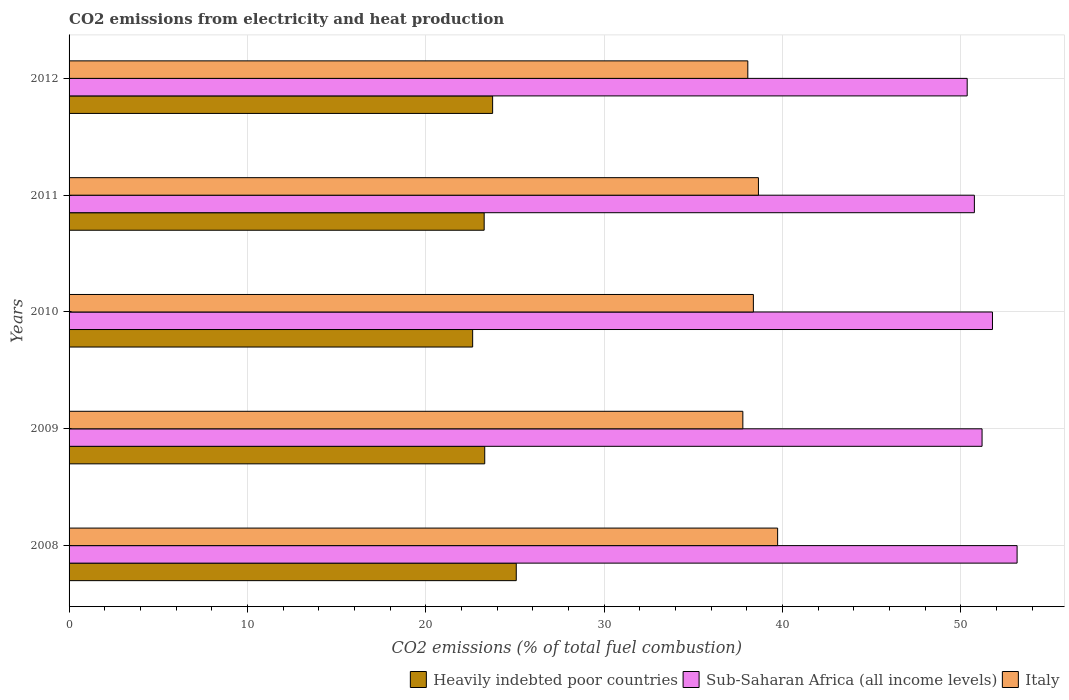How many different coloured bars are there?
Give a very brief answer. 3. How many groups of bars are there?
Offer a very short reply. 5. How many bars are there on the 2nd tick from the bottom?
Offer a terse response. 3. What is the label of the 4th group of bars from the top?
Your answer should be very brief. 2009. In how many cases, is the number of bars for a given year not equal to the number of legend labels?
Provide a succinct answer. 0. What is the amount of CO2 emitted in Sub-Saharan Africa (all income levels) in 2009?
Your response must be concise. 51.2. Across all years, what is the maximum amount of CO2 emitted in Sub-Saharan Africa (all income levels)?
Make the answer very short. 53.16. Across all years, what is the minimum amount of CO2 emitted in Heavily indebted poor countries?
Offer a terse response. 22.63. In which year was the amount of CO2 emitted in Heavily indebted poor countries minimum?
Offer a terse response. 2010. What is the total amount of CO2 emitted in Sub-Saharan Africa (all income levels) in the graph?
Offer a terse response. 257.26. What is the difference between the amount of CO2 emitted in Sub-Saharan Africa (all income levels) in 2008 and that in 2010?
Your answer should be very brief. 1.38. What is the difference between the amount of CO2 emitted in Italy in 2010 and the amount of CO2 emitted in Heavily indebted poor countries in 2009?
Offer a very short reply. 15.06. What is the average amount of CO2 emitted in Italy per year?
Offer a very short reply. 38.52. In the year 2009, what is the difference between the amount of CO2 emitted in Heavily indebted poor countries and amount of CO2 emitted in Sub-Saharan Africa (all income levels)?
Provide a short and direct response. -27.89. In how many years, is the amount of CO2 emitted in Heavily indebted poor countries greater than 42 %?
Ensure brevity in your answer.  0. What is the ratio of the amount of CO2 emitted in Italy in 2008 to that in 2012?
Give a very brief answer. 1.04. Is the amount of CO2 emitted in Sub-Saharan Africa (all income levels) in 2008 less than that in 2011?
Your answer should be compact. No. Is the difference between the amount of CO2 emitted in Heavily indebted poor countries in 2011 and 2012 greater than the difference between the amount of CO2 emitted in Sub-Saharan Africa (all income levels) in 2011 and 2012?
Ensure brevity in your answer.  No. What is the difference between the highest and the second highest amount of CO2 emitted in Italy?
Offer a very short reply. 1.08. What is the difference between the highest and the lowest amount of CO2 emitted in Heavily indebted poor countries?
Give a very brief answer. 2.45. Is the sum of the amount of CO2 emitted in Sub-Saharan Africa (all income levels) in 2011 and 2012 greater than the maximum amount of CO2 emitted in Heavily indebted poor countries across all years?
Offer a very short reply. Yes. What does the 2nd bar from the top in 2009 represents?
Your answer should be very brief. Sub-Saharan Africa (all income levels). What does the 2nd bar from the bottom in 2010 represents?
Ensure brevity in your answer.  Sub-Saharan Africa (all income levels). Is it the case that in every year, the sum of the amount of CO2 emitted in Sub-Saharan Africa (all income levels) and amount of CO2 emitted in Heavily indebted poor countries is greater than the amount of CO2 emitted in Italy?
Make the answer very short. Yes. Are all the bars in the graph horizontal?
Keep it short and to the point. Yes. How many years are there in the graph?
Your answer should be very brief. 5. Does the graph contain any zero values?
Keep it short and to the point. No. Does the graph contain grids?
Ensure brevity in your answer.  Yes. How many legend labels are there?
Give a very brief answer. 3. How are the legend labels stacked?
Provide a succinct answer. Horizontal. What is the title of the graph?
Your answer should be very brief. CO2 emissions from electricity and heat production. What is the label or title of the X-axis?
Offer a terse response. CO2 emissions (% of total fuel combustion). What is the CO2 emissions (% of total fuel combustion) in Heavily indebted poor countries in 2008?
Give a very brief answer. 25.08. What is the CO2 emissions (% of total fuel combustion) in Sub-Saharan Africa (all income levels) in 2008?
Your answer should be compact. 53.16. What is the CO2 emissions (% of total fuel combustion) of Italy in 2008?
Make the answer very short. 39.73. What is the CO2 emissions (% of total fuel combustion) of Heavily indebted poor countries in 2009?
Your answer should be very brief. 23.31. What is the CO2 emissions (% of total fuel combustion) in Sub-Saharan Africa (all income levels) in 2009?
Give a very brief answer. 51.2. What is the CO2 emissions (% of total fuel combustion) in Italy in 2009?
Your response must be concise. 37.78. What is the CO2 emissions (% of total fuel combustion) in Heavily indebted poor countries in 2010?
Your answer should be compact. 22.63. What is the CO2 emissions (% of total fuel combustion) of Sub-Saharan Africa (all income levels) in 2010?
Provide a succinct answer. 51.78. What is the CO2 emissions (% of total fuel combustion) of Italy in 2010?
Make the answer very short. 38.37. What is the CO2 emissions (% of total fuel combustion) of Heavily indebted poor countries in 2011?
Your answer should be compact. 23.28. What is the CO2 emissions (% of total fuel combustion) of Sub-Saharan Africa (all income levels) in 2011?
Your response must be concise. 50.77. What is the CO2 emissions (% of total fuel combustion) in Italy in 2011?
Offer a terse response. 38.66. What is the CO2 emissions (% of total fuel combustion) of Heavily indebted poor countries in 2012?
Your response must be concise. 23.75. What is the CO2 emissions (% of total fuel combustion) of Sub-Saharan Africa (all income levels) in 2012?
Offer a terse response. 50.36. What is the CO2 emissions (% of total fuel combustion) of Italy in 2012?
Your answer should be compact. 38.06. Across all years, what is the maximum CO2 emissions (% of total fuel combustion) in Heavily indebted poor countries?
Your answer should be compact. 25.08. Across all years, what is the maximum CO2 emissions (% of total fuel combustion) of Sub-Saharan Africa (all income levels)?
Make the answer very short. 53.16. Across all years, what is the maximum CO2 emissions (% of total fuel combustion) of Italy?
Your answer should be compact. 39.73. Across all years, what is the minimum CO2 emissions (% of total fuel combustion) of Heavily indebted poor countries?
Offer a terse response. 22.63. Across all years, what is the minimum CO2 emissions (% of total fuel combustion) of Sub-Saharan Africa (all income levels)?
Your answer should be compact. 50.36. Across all years, what is the minimum CO2 emissions (% of total fuel combustion) of Italy?
Offer a terse response. 37.78. What is the total CO2 emissions (% of total fuel combustion) in Heavily indebted poor countries in the graph?
Offer a very short reply. 118.04. What is the total CO2 emissions (% of total fuel combustion) of Sub-Saharan Africa (all income levels) in the graph?
Provide a short and direct response. 257.26. What is the total CO2 emissions (% of total fuel combustion) of Italy in the graph?
Keep it short and to the point. 192.6. What is the difference between the CO2 emissions (% of total fuel combustion) of Heavily indebted poor countries in 2008 and that in 2009?
Offer a very short reply. 1.77. What is the difference between the CO2 emissions (% of total fuel combustion) in Sub-Saharan Africa (all income levels) in 2008 and that in 2009?
Your answer should be compact. 1.96. What is the difference between the CO2 emissions (% of total fuel combustion) of Italy in 2008 and that in 2009?
Your answer should be compact. 1.95. What is the difference between the CO2 emissions (% of total fuel combustion) in Heavily indebted poor countries in 2008 and that in 2010?
Your answer should be very brief. 2.45. What is the difference between the CO2 emissions (% of total fuel combustion) in Sub-Saharan Africa (all income levels) in 2008 and that in 2010?
Your response must be concise. 1.38. What is the difference between the CO2 emissions (% of total fuel combustion) of Italy in 2008 and that in 2010?
Your answer should be very brief. 1.36. What is the difference between the CO2 emissions (% of total fuel combustion) in Heavily indebted poor countries in 2008 and that in 2011?
Your answer should be compact. 1.8. What is the difference between the CO2 emissions (% of total fuel combustion) in Sub-Saharan Africa (all income levels) in 2008 and that in 2011?
Provide a succinct answer. 2.4. What is the difference between the CO2 emissions (% of total fuel combustion) of Italy in 2008 and that in 2011?
Ensure brevity in your answer.  1.08. What is the difference between the CO2 emissions (% of total fuel combustion) of Heavily indebted poor countries in 2008 and that in 2012?
Offer a terse response. 1.33. What is the difference between the CO2 emissions (% of total fuel combustion) of Sub-Saharan Africa (all income levels) in 2008 and that in 2012?
Give a very brief answer. 2.8. What is the difference between the CO2 emissions (% of total fuel combustion) of Italy in 2008 and that in 2012?
Ensure brevity in your answer.  1.67. What is the difference between the CO2 emissions (% of total fuel combustion) in Heavily indebted poor countries in 2009 and that in 2010?
Your response must be concise. 0.68. What is the difference between the CO2 emissions (% of total fuel combustion) of Sub-Saharan Africa (all income levels) in 2009 and that in 2010?
Your answer should be very brief. -0.58. What is the difference between the CO2 emissions (% of total fuel combustion) in Italy in 2009 and that in 2010?
Provide a short and direct response. -0.59. What is the difference between the CO2 emissions (% of total fuel combustion) in Heavily indebted poor countries in 2009 and that in 2011?
Provide a short and direct response. 0.03. What is the difference between the CO2 emissions (% of total fuel combustion) of Sub-Saharan Africa (all income levels) in 2009 and that in 2011?
Make the answer very short. 0.43. What is the difference between the CO2 emissions (% of total fuel combustion) of Italy in 2009 and that in 2011?
Keep it short and to the point. -0.87. What is the difference between the CO2 emissions (% of total fuel combustion) of Heavily indebted poor countries in 2009 and that in 2012?
Offer a terse response. -0.44. What is the difference between the CO2 emissions (% of total fuel combustion) of Sub-Saharan Africa (all income levels) in 2009 and that in 2012?
Provide a succinct answer. 0.83. What is the difference between the CO2 emissions (% of total fuel combustion) of Italy in 2009 and that in 2012?
Your answer should be compact. -0.28. What is the difference between the CO2 emissions (% of total fuel combustion) in Heavily indebted poor countries in 2010 and that in 2011?
Provide a short and direct response. -0.65. What is the difference between the CO2 emissions (% of total fuel combustion) of Sub-Saharan Africa (all income levels) in 2010 and that in 2011?
Your answer should be very brief. 1.01. What is the difference between the CO2 emissions (% of total fuel combustion) of Italy in 2010 and that in 2011?
Keep it short and to the point. -0.28. What is the difference between the CO2 emissions (% of total fuel combustion) in Heavily indebted poor countries in 2010 and that in 2012?
Provide a short and direct response. -1.12. What is the difference between the CO2 emissions (% of total fuel combustion) in Sub-Saharan Africa (all income levels) in 2010 and that in 2012?
Give a very brief answer. 1.42. What is the difference between the CO2 emissions (% of total fuel combustion) in Italy in 2010 and that in 2012?
Your response must be concise. 0.31. What is the difference between the CO2 emissions (% of total fuel combustion) in Heavily indebted poor countries in 2011 and that in 2012?
Give a very brief answer. -0.47. What is the difference between the CO2 emissions (% of total fuel combustion) of Sub-Saharan Africa (all income levels) in 2011 and that in 2012?
Make the answer very short. 0.4. What is the difference between the CO2 emissions (% of total fuel combustion) in Italy in 2011 and that in 2012?
Make the answer very short. 0.6. What is the difference between the CO2 emissions (% of total fuel combustion) of Heavily indebted poor countries in 2008 and the CO2 emissions (% of total fuel combustion) of Sub-Saharan Africa (all income levels) in 2009?
Provide a short and direct response. -26.12. What is the difference between the CO2 emissions (% of total fuel combustion) of Heavily indebted poor countries in 2008 and the CO2 emissions (% of total fuel combustion) of Italy in 2009?
Give a very brief answer. -12.71. What is the difference between the CO2 emissions (% of total fuel combustion) in Sub-Saharan Africa (all income levels) in 2008 and the CO2 emissions (% of total fuel combustion) in Italy in 2009?
Your response must be concise. 15.38. What is the difference between the CO2 emissions (% of total fuel combustion) in Heavily indebted poor countries in 2008 and the CO2 emissions (% of total fuel combustion) in Sub-Saharan Africa (all income levels) in 2010?
Give a very brief answer. -26.7. What is the difference between the CO2 emissions (% of total fuel combustion) in Heavily indebted poor countries in 2008 and the CO2 emissions (% of total fuel combustion) in Italy in 2010?
Your answer should be compact. -13.3. What is the difference between the CO2 emissions (% of total fuel combustion) of Sub-Saharan Africa (all income levels) in 2008 and the CO2 emissions (% of total fuel combustion) of Italy in 2010?
Make the answer very short. 14.79. What is the difference between the CO2 emissions (% of total fuel combustion) in Heavily indebted poor countries in 2008 and the CO2 emissions (% of total fuel combustion) in Sub-Saharan Africa (all income levels) in 2011?
Provide a short and direct response. -25.69. What is the difference between the CO2 emissions (% of total fuel combustion) of Heavily indebted poor countries in 2008 and the CO2 emissions (% of total fuel combustion) of Italy in 2011?
Make the answer very short. -13.58. What is the difference between the CO2 emissions (% of total fuel combustion) of Sub-Saharan Africa (all income levels) in 2008 and the CO2 emissions (% of total fuel combustion) of Italy in 2011?
Your answer should be very brief. 14.5. What is the difference between the CO2 emissions (% of total fuel combustion) of Heavily indebted poor countries in 2008 and the CO2 emissions (% of total fuel combustion) of Sub-Saharan Africa (all income levels) in 2012?
Your response must be concise. -25.29. What is the difference between the CO2 emissions (% of total fuel combustion) of Heavily indebted poor countries in 2008 and the CO2 emissions (% of total fuel combustion) of Italy in 2012?
Your answer should be compact. -12.98. What is the difference between the CO2 emissions (% of total fuel combustion) in Sub-Saharan Africa (all income levels) in 2008 and the CO2 emissions (% of total fuel combustion) in Italy in 2012?
Ensure brevity in your answer.  15.1. What is the difference between the CO2 emissions (% of total fuel combustion) of Heavily indebted poor countries in 2009 and the CO2 emissions (% of total fuel combustion) of Sub-Saharan Africa (all income levels) in 2010?
Give a very brief answer. -28.47. What is the difference between the CO2 emissions (% of total fuel combustion) of Heavily indebted poor countries in 2009 and the CO2 emissions (% of total fuel combustion) of Italy in 2010?
Give a very brief answer. -15.06. What is the difference between the CO2 emissions (% of total fuel combustion) of Sub-Saharan Africa (all income levels) in 2009 and the CO2 emissions (% of total fuel combustion) of Italy in 2010?
Your answer should be compact. 12.82. What is the difference between the CO2 emissions (% of total fuel combustion) in Heavily indebted poor countries in 2009 and the CO2 emissions (% of total fuel combustion) in Sub-Saharan Africa (all income levels) in 2011?
Your answer should be very brief. -27.46. What is the difference between the CO2 emissions (% of total fuel combustion) in Heavily indebted poor countries in 2009 and the CO2 emissions (% of total fuel combustion) in Italy in 2011?
Make the answer very short. -15.35. What is the difference between the CO2 emissions (% of total fuel combustion) of Sub-Saharan Africa (all income levels) in 2009 and the CO2 emissions (% of total fuel combustion) of Italy in 2011?
Give a very brief answer. 12.54. What is the difference between the CO2 emissions (% of total fuel combustion) in Heavily indebted poor countries in 2009 and the CO2 emissions (% of total fuel combustion) in Sub-Saharan Africa (all income levels) in 2012?
Your answer should be compact. -27.05. What is the difference between the CO2 emissions (% of total fuel combustion) in Heavily indebted poor countries in 2009 and the CO2 emissions (% of total fuel combustion) in Italy in 2012?
Ensure brevity in your answer.  -14.75. What is the difference between the CO2 emissions (% of total fuel combustion) of Sub-Saharan Africa (all income levels) in 2009 and the CO2 emissions (% of total fuel combustion) of Italy in 2012?
Give a very brief answer. 13.14. What is the difference between the CO2 emissions (% of total fuel combustion) of Heavily indebted poor countries in 2010 and the CO2 emissions (% of total fuel combustion) of Sub-Saharan Africa (all income levels) in 2011?
Provide a short and direct response. -28.13. What is the difference between the CO2 emissions (% of total fuel combustion) in Heavily indebted poor countries in 2010 and the CO2 emissions (% of total fuel combustion) in Italy in 2011?
Provide a succinct answer. -16.03. What is the difference between the CO2 emissions (% of total fuel combustion) in Sub-Saharan Africa (all income levels) in 2010 and the CO2 emissions (% of total fuel combustion) in Italy in 2011?
Offer a terse response. 13.12. What is the difference between the CO2 emissions (% of total fuel combustion) of Heavily indebted poor countries in 2010 and the CO2 emissions (% of total fuel combustion) of Sub-Saharan Africa (all income levels) in 2012?
Your response must be concise. -27.73. What is the difference between the CO2 emissions (% of total fuel combustion) of Heavily indebted poor countries in 2010 and the CO2 emissions (% of total fuel combustion) of Italy in 2012?
Provide a succinct answer. -15.43. What is the difference between the CO2 emissions (% of total fuel combustion) of Sub-Saharan Africa (all income levels) in 2010 and the CO2 emissions (% of total fuel combustion) of Italy in 2012?
Provide a succinct answer. 13.72. What is the difference between the CO2 emissions (% of total fuel combustion) of Heavily indebted poor countries in 2011 and the CO2 emissions (% of total fuel combustion) of Sub-Saharan Africa (all income levels) in 2012?
Your answer should be very brief. -27.09. What is the difference between the CO2 emissions (% of total fuel combustion) of Heavily indebted poor countries in 2011 and the CO2 emissions (% of total fuel combustion) of Italy in 2012?
Provide a short and direct response. -14.78. What is the difference between the CO2 emissions (% of total fuel combustion) of Sub-Saharan Africa (all income levels) in 2011 and the CO2 emissions (% of total fuel combustion) of Italy in 2012?
Make the answer very short. 12.7. What is the average CO2 emissions (% of total fuel combustion) of Heavily indebted poor countries per year?
Offer a very short reply. 23.61. What is the average CO2 emissions (% of total fuel combustion) in Sub-Saharan Africa (all income levels) per year?
Make the answer very short. 51.45. What is the average CO2 emissions (% of total fuel combustion) in Italy per year?
Your response must be concise. 38.52. In the year 2008, what is the difference between the CO2 emissions (% of total fuel combustion) in Heavily indebted poor countries and CO2 emissions (% of total fuel combustion) in Sub-Saharan Africa (all income levels)?
Your response must be concise. -28.08. In the year 2008, what is the difference between the CO2 emissions (% of total fuel combustion) in Heavily indebted poor countries and CO2 emissions (% of total fuel combustion) in Italy?
Provide a short and direct response. -14.66. In the year 2008, what is the difference between the CO2 emissions (% of total fuel combustion) in Sub-Saharan Africa (all income levels) and CO2 emissions (% of total fuel combustion) in Italy?
Keep it short and to the point. 13.43. In the year 2009, what is the difference between the CO2 emissions (% of total fuel combustion) in Heavily indebted poor countries and CO2 emissions (% of total fuel combustion) in Sub-Saharan Africa (all income levels)?
Your response must be concise. -27.89. In the year 2009, what is the difference between the CO2 emissions (% of total fuel combustion) in Heavily indebted poor countries and CO2 emissions (% of total fuel combustion) in Italy?
Make the answer very short. -14.47. In the year 2009, what is the difference between the CO2 emissions (% of total fuel combustion) of Sub-Saharan Africa (all income levels) and CO2 emissions (% of total fuel combustion) of Italy?
Offer a terse response. 13.41. In the year 2010, what is the difference between the CO2 emissions (% of total fuel combustion) in Heavily indebted poor countries and CO2 emissions (% of total fuel combustion) in Sub-Saharan Africa (all income levels)?
Offer a terse response. -29.15. In the year 2010, what is the difference between the CO2 emissions (% of total fuel combustion) in Heavily indebted poor countries and CO2 emissions (% of total fuel combustion) in Italy?
Offer a terse response. -15.74. In the year 2010, what is the difference between the CO2 emissions (% of total fuel combustion) in Sub-Saharan Africa (all income levels) and CO2 emissions (% of total fuel combustion) in Italy?
Keep it short and to the point. 13.41. In the year 2011, what is the difference between the CO2 emissions (% of total fuel combustion) in Heavily indebted poor countries and CO2 emissions (% of total fuel combustion) in Sub-Saharan Africa (all income levels)?
Give a very brief answer. -27.49. In the year 2011, what is the difference between the CO2 emissions (% of total fuel combustion) of Heavily indebted poor countries and CO2 emissions (% of total fuel combustion) of Italy?
Provide a succinct answer. -15.38. In the year 2011, what is the difference between the CO2 emissions (% of total fuel combustion) in Sub-Saharan Africa (all income levels) and CO2 emissions (% of total fuel combustion) in Italy?
Make the answer very short. 12.11. In the year 2012, what is the difference between the CO2 emissions (% of total fuel combustion) in Heavily indebted poor countries and CO2 emissions (% of total fuel combustion) in Sub-Saharan Africa (all income levels)?
Give a very brief answer. -26.61. In the year 2012, what is the difference between the CO2 emissions (% of total fuel combustion) in Heavily indebted poor countries and CO2 emissions (% of total fuel combustion) in Italy?
Make the answer very short. -14.31. In the year 2012, what is the difference between the CO2 emissions (% of total fuel combustion) of Sub-Saharan Africa (all income levels) and CO2 emissions (% of total fuel combustion) of Italy?
Your answer should be compact. 12.3. What is the ratio of the CO2 emissions (% of total fuel combustion) of Heavily indebted poor countries in 2008 to that in 2009?
Provide a short and direct response. 1.08. What is the ratio of the CO2 emissions (% of total fuel combustion) of Sub-Saharan Africa (all income levels) in 2008 to that in 2009?
Your answer should be compact. 1.04. What is the ratio of the CO2 emissions (% of total fuel combustion) in Italy in 2008 to that in 2009?
Offer a very short reply. 1.05. What is the ratio of the CO2 emissions (% of total fuel combustion) in Heavily indebted poor countries in 2008 to that in 2010?
Your answer should be compact. 1.11. What is the ratio of the CO2 emissions (% of total fuel combustion) of Sub-Saharan Africa (all income levels) in 2008 to that in 2010?
Your answer should be very brief. 1.03. What is the ratio of the CO2 emissions (% of total fuel combustion) in Italy in 2008 to that in 2010?
Make the answer very short. 1.04. What is the ratio of the CO2 emissions (% of total fuel combustion) in Heavily indebted poor countries in 2008 to that in 2011?
Your answer should be compact. 1.08. What is the ratio of the CO2 emissions (% of total fuel combustion) of Sub-Saharan Africa (all income levels) in 2008 to that in 2011?
Offer a very short reply. 1.05. What is the ratio of the CO2 emissions (% of total fuel combustion) of Italy in 2008 to that in 2011?
Your answer should be compact. 1.03. What is the ratio of the CO2 emissions (% of total fuel combustion) of Heavily indebted poor countries in 2008 to that in 2012?
Give a very brief answer. 1.06. What is the ratio of the CO2 emissions (% of total fuel combustion) in Sub-Saharan Africa (all income levels) in 2008 to that in 2012?
Your answer should be very brief. 1.06. What is the ratio of the CO2 emissions (% of total fuel combustion) in Italy in 2008 to that in 2012?
Provide a succinct answer. 1.04. What is the ratio of the CO2 emissions (% of total fuel combustion) in Heavily indebted poor countries in 2009 to that in 2010?
Offer a very short reply. 1.03. What is the ratio of the CO2 emissions (% of total fuel combustion) in Sub-Saharan Africa (all income levels) in 2009 to that in 2010?
Your response must be concise. 0.99. What is the ratio of the CO2 emissions (% of total fuel combustion) in Italy in 2009 to that in 2010?
Make the answer very short. 0.98. What is the ratio of the CO2 emissions (% of total fuel combustion) of Sub-Saharan Africa (all income levels) in 2009 to that in 2011?
Your response must be concise. 1.01. What is the ratio of the CO2 emissions (% of total fuel combustion) in Italy in 2009 to that in 2011?
Your answer should be very brief. 0.98. What is the ratio of the CO2 emissions (% of total fuel combustion) in Heavily indebted poor countries in 2009 to that in 2012?
Ensure brevity in your answer.  0.98. What is the ratio of the CO2 emissions (% of total fuel combustion) of Sub-Saharan Africa (all income levels) in 2009 to that in 2012?
Your answer should be very brief. 1.02. What is the ratio of the CO2 emissions (% of total fuel combustion) in Italy in 2009 to that in 2012?
Give a very brief answer. 0.99. What is the ratio of the CO2 emissions (% of total fuel combustion) of Heavily indebted poor countries in 2010 to that in 2011?
Your answer should be compact. 0.97. What is the ratio of the CO2 emissions (% of total fuel combustion) of Italy in 2010 to that in 2011?
Your response must be concise. 0.99. What is the ratio of the CO2 emissions (% of total fuel combustion) of Heavily indebted poor countries in 2010 to that in 2012?
Offer a terse response. 0.95. What is the ratio of the CO2 emissions (% of total fuel combustion) in Sub-Saharan Africa (all income levels) in 2010 to that in 2012?
Give a very brief answer. 1.03. What is the ratio of the CO2 emissions (% of total fuel combustion) of Italy in 2010 to that in 2012?
Make the answer very short. 1.01. What is the ratio of the CO2 emissions (% of total fuel combustion) of Italy in 2011 to that in 2012?
Offer a very short reply. 1.02. What is the difference between the highest and the second highest CO2 emissions (% of total fuel combustion) in Heavily indebted poor countries?
Provide a short and direct response. 1.33. What is the difference between the highest and the second highest CO2 emissions (% of total fuel combustion) in Sub-Saharan Africa (all income levels)?
Provide a succinct answer. 1.38. What is the difference between the highest and the second highest CO2 emissions (% of total fuel combustion) of Italy?
Your answer should be compact. 1.08. What is the difference between the highest and the lowest CO2 emissions (% of total fuel combustion) in Heavily indebted poor countries?
Make the answer very short. 2.45. What is the difference between the highest and the lowest CO2 emissions (% of total fuel combustion) of Sub-Saharan Africa (all income levels)?
Provide a short and direct response. 2.8. What is the difference between the highest and the lowest CO2 emissions (% of total fuel combustion) of Italy?
Offer a very short reply. 1.95. 